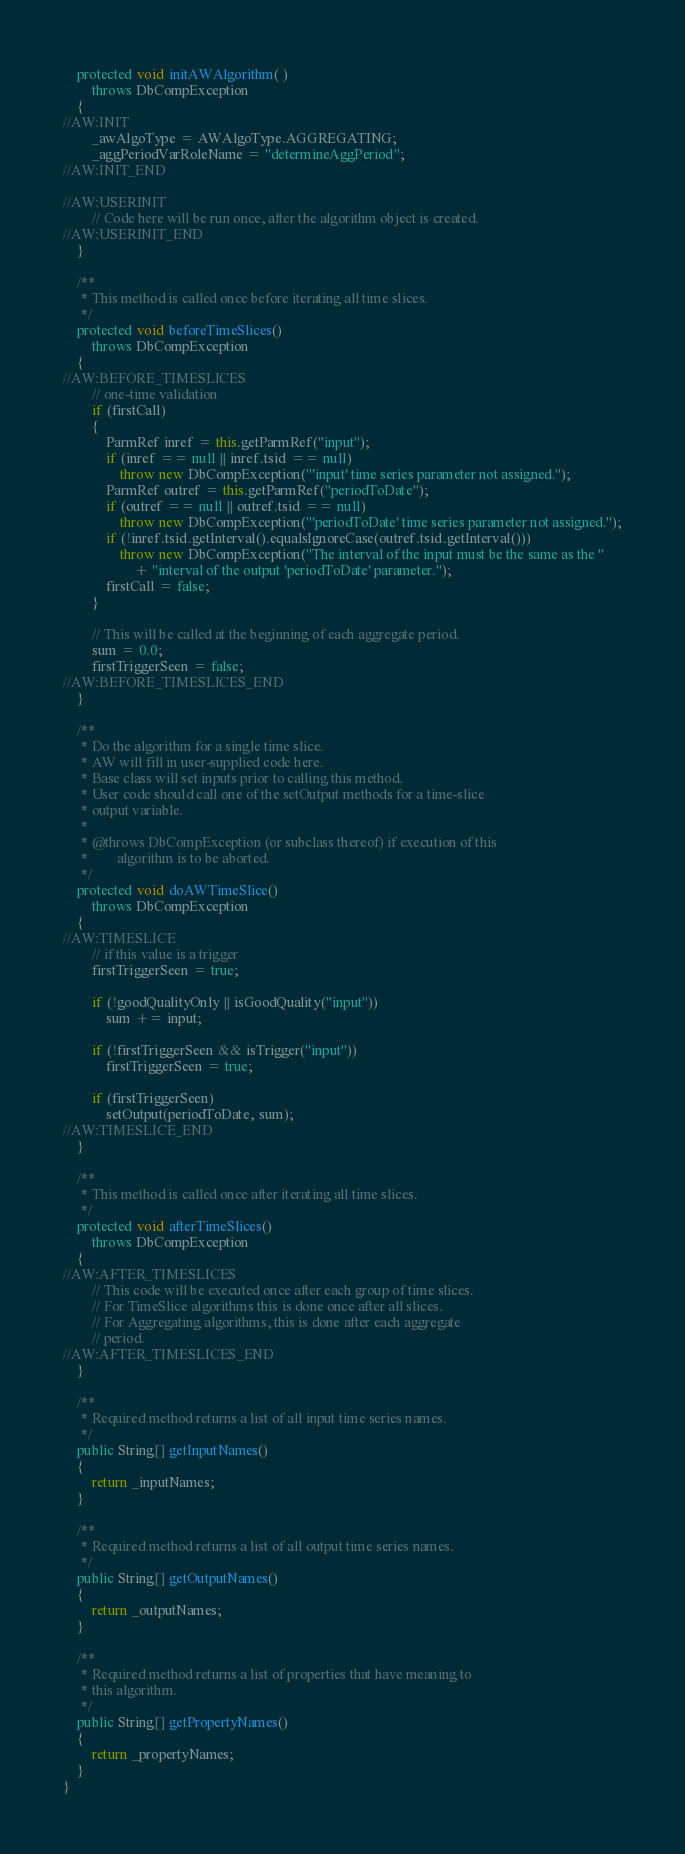<code> <loc_0><loc_0><loc_500><loc_500><_Java_>	protected void initAWAlgorithm( )
		throws DbCompException
	{
//AW:INIT
		_awAlgoType = AWAlgoType.AGGREGATING;
		_aggPeriodVarRoleName = "determineAggPeriod";
//AW:INIT_END

//AW:USERINIT
		// Code here will be run once, after the algorithm object is created.
//AW:USERINIT_END
	}
	
	/**
	 * This method is called once before iterating all time slices.
	 */
	protected void beforeTimeSlices()
		throws DbCompException
	{
//AW:BEFORE_TIMESLICES
		// one-time validation
		if (firstCall)
		{
			ParmRef inref = this.getParmRef("input");
			if (inref == null || inref.tsid == null)
				throw new DbCompException("'input' time series parameter not assigned.");
			ParmRef outref = this.getParmRef("periodToDate");
			if (outref == null || outref.tsid == null)
				throw new DbCompException("'periodToDate' time series parameter not assigned.");
			if (!inref.tsid.getInterval().equalsIgnoreCase(outref.tsid.getInterval()))
				throw new DbCompException("The interval of the input must be the same as the "
					+ "interval of the output 'periodToDate' parameter.");
			firstCall = false;
		}
		
		// This will be called at the beginning of each aggregate period.
		sum = 0.0;
		firstTriggerSeen = false;
//AW:BEFORE_TIMESLICES_END
	}

	/**
	 * Do the algorithm for a single time slice.
	 * AW will fill in user-supplied code here.
	 * Base class will set inputs prior to calling this method.
	 * User code should call one of the setOutput methods for a time-slice
	 * output variable.
	 *
	 * @throws DbCompException (or subclass thereof) if execution of this
	 *        algorithm is to be aborted.
	 */
	protected void doAWTimeSlice()
		throws DbCompException
	{
//AW:TIMESLICE
		// if this value is a trigger
		firstTriggerSeen = true;
		
		if (!goodQualityOnly || isGoodQuality("input"))
			sum += input;
		
		if (!firstTriggerSeen && isTrigger("input"))
			firstTriggerSeen = true;
		
		if (firstTriggerSeen)
			setOutput(periodToDate, sum);
//AW:TIMESLICE_END
	}

	/**
	 * This method is called once after iterating all time slices.
	 */
	protected void afterTimeSlices()
		throws DbCompException
	{
//AW:AFTER_TIMESLICES
		// This code will be executed once after each group of time slices.
		// For TimeSlice algorithms this is done once after all slices.
		// For Aggregating algorithms, this is done after each aggregate
		// period.
//AW:AFTER_TIMESLICES_END
	}

	/**
	 * Required method returns a list of all input time series names.
	 */
	public String[] getInputNames()
	{
		return _inputNames;
	}

	/**
	 * Required method returns a list of all output time series names.
	 */
	public String[] getOutputNames()
	{
		return _outputNames;
	}

	/**
	 * Required method returns a list of properties that have meaning to
	 * this algorithm.
	 */
	public String[] getPropertyNames()
	{
		return _propertyNames;
	}
}
</code> 